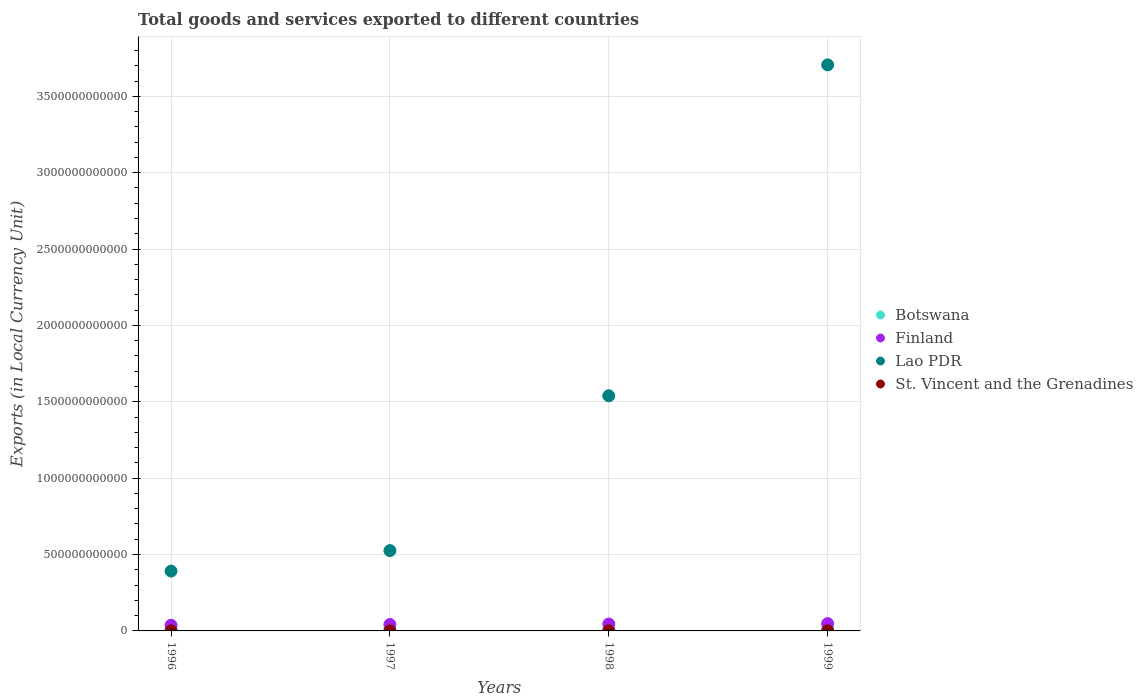What is the Amount of goods and services exports in Botswana in 1999?
Offer a very short reply. 1.40e+1. Across all years, what is the maximum Amount of goods and services exports in St. Vincent and the Grenadines?
Give a very brief answer. 4.78e+08. Across all years, what is the minimum Amount of goods and services exports in Botswana?
Offer a terse response. 8.67e+09. In which year was the Amount of goods and services exports in St. Vincent and the Grenadines minimum?
Make the answer very short. 1997. What is the total Amount of goods and services exports in Lao PDR in the graph?
Your answer should be compact. 6.16e+12. What is the difference between the Amount of goods and services exports in Lao PDR in 1997 and that in 1999?
Offer a very short reply. -3.18e+12. What is the difference between the Amount of goods and services exports in Botswana in 1997 and the Amount of goods and services exports in Lao PDR in 1999?
Make the answer very short. -3.69e+12. What is the average Amount of goods and services exports in St. Vincent and the Grenadines per year?
Offer a terse response. 4.27e+08. In the year 1999, what is the difference between the Amount of goods and services exports in Botswana and Amount of goods and services exports in St. Vincent and the Grenadines?
Make the answer very short. 1.35e+1. What is the ratio of the Amount of goods and services exports in St. Vincent and the Grenadines in 1997 to that in 1998?
Your answer should be very brief. 0.94. Is the difference between the Amount of goods and services exports in Botswana in 1996 and 1998 greater than the difference between the Amount of goods and services exports in St. Vincent and the Grenadines in 1996 and 1998?
Ensure brevity in your answer.  No. What is the difference between the highest and the second highest Amount of goods and services exports in Botswana?
Your answer should be very brief. 2.84e+09. What is the difference between the highest and the lowest Amount of goods and services exports in Lao PDR?
Keep it short and to the point. 3.31e+12. Is the sum of the Amount of goods and services exports in St. Vincent and the Grenadines in 1996 and 1999 greater than the maximum Amount of goods and services exports in Botswana across all years?
Offer a very short reply. No. Is the Amount of goods and services exports in St. Vincent and the Grenadines strictly greater than the Amount of goods and services exports in Finland over the years?
Your answer should be very brief. No. What is the difference between two consecutive major ticks on the Y-axis?
Provide a short and direct response. 5.00e+11. Are the values on the major ticks of Y-axis written in scientific E-notation?
Keep it short and to the point. No. Where does the legend appear in the graph?
Your answer should be very brief. Center right. How are the legend labels stacked?
Your response must be concise. Vertical. What is the title of the graph?
Offer a very short reply. Total goods and services exported to different countries. What is the label or title of the Y-axis?
Your answer should be compact. Exports (in Local Currency Unit). What is the Exports (in Local Currency Unit) in Botswana in 1996?
Your answer should be very brief. 8.67e+09. What is the Exports (in Local Currency Unit) in Finland in 1996?
Your answer should be very brief. 3.71e+1. What is the Exports (in Local Currency Unit) of Lao PDR in 1996?
Give a very brief answer. 3.92e+11. What is the Exports (in Local Currency Unit) in St. Vincent and the Grenadines in 1996?
Your response must be concise. 4.03e+08. What is the Exports (in Local Currency Unit) in Botswana in 1997?
Make the answer very short. 1.12e+1. What is the Exports (in Local Currency Unit) in Finland in 1997?
Offer a terse response. 4.19e+1. What is the Exports (in Local Currency Unit) in Lao PDR in 1997?
Ensure brevity in your answer.  5.26e+11. What is the Exports (in Local Currency Unit) in St. Vincent and the Grenadines in 1997?
Give a very brief answer. 4.01e+08. What is the Exports (in Local Currency Unit) in Botswana in 1998?
Offer a very short reply. 9.98e+09. What is the Exports (in Local Currency Unit) in Finland in 1998?
Provide a succinct answer. 4.51e+1. What is the Exports (in Local Currency Unit) of Lao PDR in 1998?
Provide a succinct answer. 1.54e+12. What is the Exports (in Local Currency Unit) of St. Vincent and the Grenadines in 1998?
Your answer should be very brief. 4.25e+08. What is the Exports (in Local Currency Unit) in Botswana in 1999?
Keep it short and to the point. 1.40e+1. What is the Exports (in Local Currency Unit) of Finland in 1999?
Offer a terse response. 4.77e+1. What is the Exports (in Local Currency Unit) in Lao PDR in 1999?
Your answer should be very brief. 3.71e+12. What is the Exports (in Local Currency Unit) in St. Vincent and the Grenadines in 1999?
Provide a short and direct response. 4.78e+08. Across all years, what is the maximum Exports (in Local Currency Unit) in Botswana?
Offer a very short reply. 1.40e+1. Across all years, what is the maximum Exports (in Local Currency Unit) in Finland?
Your answer should be compact. 4.77e+1. Across all years, what is the maximum Exports (in Local Currency Unit) of Lao PDR?
Keep it short and to the point. 3.71e+12. Across all years, what is the maximum Exports (in Local Currency Unit) of St. Vincent and the Grenadines?
Your answer should be compact. 4.78e+08. Across all years, what is the minimum Exports (in Local Currency Unit) in Botswana?
Offer a very short reply. 8.67e+09. Across all years, what is the minimum Exports (in Local Currency Unit) in Finland?
Provide a succinct answer. 3.71e+1. Across all years, what is the minimum Exports (in Local Currency Unit) in Lao PDR?
Offer a very short reply. 3.92e+11. Across all years, what is the minimum Exports (in Local Currency Unit) of St. Vincent and the Grenadines?
Keep it short and to the point. 4.01e+08. What is the total Exports (in Local Currency Unit) in Botswana in the graph?
Give a very brief answer. 4.38e+1. What is the total Exports (in Local Currency Unit) of Finland in the graph?
Your answer should be very brief. 1.72e+11. What is the total Exports (in Local Currency Unit) of Lao PDR in the graph?
Provide a succinct answer. 6.16e+12. What is the total Exports (in Local Currency Unit) in St. Vincent and the Grenadines in the graph?
Offer a very short reply. 1.71e+09. What is the difference between the Exports (in Local Currency Unit) of Botswana in 1996 and that in 1997?
Offer a terse response. -2.48e+09. What is the difference between the Exports (in Local Currency Unit) of Finland in 1996 and that in 1997?
Provide a succinct answer. -4.78e+09. What is the difference between the Exports (in Local Currency Unit) in Lao PDR in 1996 and that in 1997?
Provide a short and direct response. -1.34e+11. What is the difference between the Exports (in Local Currency Unit) of St. Vincent and the Grenadines in 1996 and that in 1997?
Provide a short and direct response. 2.41e+06. What is the difference between the Exports (in Local Currency Unit) in Botswana in 1996 and that in 1998?
Make the answer very short. -1.30e+09. What is the difference between the Exports (in Local Currency Unit) in Finland in 1996 and that in 1998?
Offer a very short reply. -8.03e+09. What is the difference between the Exports (in Local Currency Unit) in Lao PDR in 1996 and that in 1998?
Ensure brevity in your answer.  -1.15e+12. What is the difference between the Exports (in Local Currency Unit) of St. Vincent and the Grenadines in 1996 and that in 1998?
Your response must be concise. -2.21e+07. What is the difference between the Exports (in Local Currency Unit) in Botswana in 1996 and that in 1999?
Your answer should be compact. -5.32e+09. What is the difference between the Exports (in Local Currency Unit) of Finland in 1996 and that in 1999?
Provide a succinct answer. -1.06e+1. What is the difference between the Exports (in Local Currency Unit) in Lao PDR in 1996 and that in 1999?
Your response must be concise. -3.31e+12. What is the difference between the Exports (in Local Currency Unit) of St. Vincent and the Grenadines in 1996 and that in 1999?
Make the answer very short. -7.55e+07. What is the difference between the Exports (in Local Currency Unit) of Botswana in 1997 and that in 1998?
Make the answer very short. 1.18e+09. What is the difference between the Exports (in Local Currency Unit) in Finland in 1997 and that in 1998?
Offer a very short reply. -3.24e+09. What is the difference between the Exports (in Local Currency Unit) of Lao PDR in 1997 and that in 1998?
Your response must be concise. -1.01e+12. What is the difference between the Exports (in Local Currency Unit) of St. Vincent and the Grenadines in 1997 and that in 1998?
Your answer should be very brief. -2.45e+07. What is the difference between the Exports (in Local Currency Unit) of Botswana in 1997 and that in 1999?
Your answer should be compact. -2.84e+09. What is the difference between the Exports (in Local Currency Unit) of Finland in 1997 and that in 1999?
Ensure brevity in your answer.  -5.87e+09. What is the difference between the Exports (in Local Currency Unit) in Lao PDR in 1997 and that in 1999?
Keep it short and to the point. -3.18e+12. What is the difference between the Exports (in Local Currency Unit) in St. Vincent and the Grenadines in 1997 and that in 1999?
Your response must be concise. -7.79e+07. What is the difference between the Exports (in Local Currency Unit) in Botswana in 1998 and that in 1999?
Provide a short and direct response. -4.02e+09. What is the difference between the Exports (in Local Currency Unit) of Finland in 1998 and that in 1999?
Keep it short and to the point. -2.62e+09. What is the difference between the Exports (in Local Currency Unit) in Lao PDR in 1998 and that in 1999?
Keep it short and to the point. -2.17e+12. What is the difference between the Exports (in Local Currency Unit) in St. Vincent and the Grenadines in 1998 and that in 1999?
Offer a very short reply. -5.34e+07. What is the difference between the Exports (in Local Currency Unit) of Botswana in 1996 and the Exports (in Local Currency Unit) of Finland in 1997?
Your answer should be very brief. -3.32e+1. What is the difference between the Exports (in Local Currency Unit) in Botswana in 1996 and the Exports (in Local Currency Unit) in Lao PDR in 1997?
Your answer should be compact. -5.17e+11. What is the difference between the Exports (in Local Currency Unit) in Botswana in 1996 and the Exports (in Local Currency Unit) in St. Vincent and the Grenadines in 1997?
Provide a succinct answer. 8.27e+09. What is the difference between the Exports (in Local Currency Unit) of Finland in 1996 and the Exports (in Local Currency Unit) of Lao PDR in 1997?
Provide a succinct answer. -4.89e+11. What is the difference between the Exports (in Local Currency Unit) of Finland in 1996 and the Exports (in Local Currency Unit) of St. Vincent and the Grenadines in 1997?
Give a very brief answer. 3.67e+1. What is the difference between the Exports (in Local Currency Unit) of Lao PDR in 1996 and the Exports (in Local Currency Unit) of St. Vincent and the Grenadines in 1997?
Offer a very short reply. 3.91e+11. What is the difference between the Exports (in Local Currency Unit) of Botswana in 1996 and the Exports (in Local Currency Unit) of Finland in 1998?
Give a very brief answer. -3.64e+1. What is the difference between the Exports (in Local Currency Unit) of Botswana in 1996 and the Exports (in Local Currency Unit) of Lao PDR in 1998?
Your response must be concise. -1.53e+12. What is the difference between the Exports (in Local Currency Unit) in Botswana in 1996 and the Exports (in Local Currency Unit) in St. Vincent and the Grenadines in 1998?
Your answer should be compact. 8.25e+09. What is the difference between the Exports (in Local Currency Unit) of Finland in 1996 and the Exports (in Local Currency Unit) of Lao PDR in 1998?
Offer a very short reply. -1.50e+12. What is the difference between the Exports (in Local Currency Unit) in Finland in 1996 and the Exports (in Local Currency Unit) in St. Vincent and the Grenadines in 1998?
Offer a terse response. 3.67e+1. What is the difference between the Exports (in Local Currency Unit) of Lao PDR in 1996 and the Exports (in Local Currency Unit) of St. Vincent and the Grenadines in 1998?
Keep it short and to the point. 3.91e+11. What is the difference between the Exports (in Local Currency Unit) in Botswana in 1996 and the Exports (in Local Currency Unit) in Finland in 1999?
Provide a short and direct response. -3.91e+1. What is the difference between the Exports (in Local Currency Unit) of Botswana in 1996 and the Exports (in Local Currency Unit) of Lao PDR in 1999?
Provide a succinct answer. -3.70e+12. What is the difference between the Exports (in Local Currency Unit) of Botswana in 1996 and the Exports (in Local Currency Unit) of St. Vincent and the Grenadines in 1999?
Your response must be concise. 8.20e+09. What is the difference between the Exports (in Local Currency Unit) in Finland in 1996 and the Exports (in Local Currency Unit) in Lao PDR in 1999?
Provide a short and direct response. -3.67e+12. What is the difference between the Exports (in Local Currency Unit) in Finland in 1996 and the Exports (in Local Currency Unit) in St. Vincent and the Grenadines in 1999?
Provide a short and direct response. 3.66e+1. What is the difference between the Exports (in Local Currency Unit) of Lao PDR in 1996 and the Exports (in Local Currency Unit) of St. Vincent and the Grenadines in 1999?
Offer a very short reply. 3.91e+11. What is the difference between the Exports (in Local Currency Unit) of Botswana in 1997 and the Exports (in Local Currency Unit) of Finland in 1998?
Your response must be concise. -3.39e+1. What is the difference between the Exports (in Local Currency Unit) in Botswana in 1997 and the Exports (in Local Currency Unit) in Lao PDR in 1998?
Your answer should be compact. -1.53e+12. What is the difference between the Exports (in Local Currency Unit) of Botswana in 1997 and the Exports (in Local Currency Unit) of St. Vincent and the Grenadines in 1998?
Your answer should be very brief. 1.07e+1. What is the difference between the Exports (in Local Currency Unit) of Finland in 1997 and the Exports (in Local Currency Unit) of Lao PDR in 1998?
Your answer should be compact. -1.50e+12. What is the difference between the Exports (in Local Currency Unit) in Finland in 1997 and the Exports (in Local Currency Unit) in St. Vincent and the Grenadines in 1998?
Your answer should be compact. 4.14e+1. What is the difference between the Exports (in Local Currency Unit) of Lao PDR in 1997 and the Exports (in Local Currency Unit) of St. Vincent and the Grenadines in 1998?
Your answer should be very brief. 5.25e+11. What is the difference between the Exports (in Local Currency Unit) in Botswana in 1997 and the Exports (in Local Currency Unit) in Finland in 1999?
Your answer should be compact. -3.66e+1. What is the difference between the Exports (in Local Currency Unit) in Botswana in 1997 and the Exports (in Local Currency Unit) in Lao PDR in 1999?
Provide a short and direct response. -3.69e+12. What is the difference between the Exports (in Local Currency Unit) of Botswana in 1997 and the Exports (in Local Currency Unit) of St. Vincent and the Grenadines in 1999?
Provide a short and direct response. 1.07e+1. What is the difference between the Exports (in Local Currency Unit) of Finland in 1997 and the Exports (in Local Currency Unit) of Lao PDR in 1999?
Your answer should be compact. -3.66e+12. What is the difference between the Exports (in Local Currency Unit) in Finland in 1997 and the Exports (in Local Currency Unit) in St. Vincent and the Grenadines in 1999?
Your response must be concise. 4.14e+1. What is the difference between the Exports (in Local Currency Unit) of Lao PDR in 1997 and the Exports (in Local Currency Unit) of St. Vincent and the Grenadines in 1999?
Make the answer very short. 5.25e+11. What is the difference between the Exports (in Local Currency Unit) in Botswana in 1998 and the Exports (in Local Currency Unit) in Finland in 1999?
Provide a short and direct response. -3.77e+1. What is the difference between the Exports (in Local Currency Unit) in Botswana in 1998 and the Exports (in Local Currency Unit) in Lao PDR in 1999?
Your answer should be very brief. -3.70e+12. What is the difference between the Exports (in Local Currency Unit) in Botswana in 1998 and the Exports (in Local Currency Unit) in St. Vincent and the Grenadines in 1999?
Provide a succinct answer. 9.50e+09. What is the difference between the Exports (in Local Currency Unit) of Finland in 1998 and the Exports (in Local Currency Unit) of Lao PDR in 1999?
Keep it short and to the point. -3.66e+12. What is the difference between the Exports (in Local Currency Unit) of Finland in 1998 and the Exports (in Local Currency Unit) of St. Vincent and the Grenadines in 1999?
Your answer should be compact. 4.46e+1. What is the difference between the Exports (in Local Currency Unit) in Lao PDR in 1998 and the Exports (in Local Currency Unit) in St. Vincent and the Grenadines in 1999?
Provide a short and direct response. 1.54e+12. What is the average Exports (in Local Currency Unit) in Botswana per year?
Your answer should be compact. 1.10e+1. What is the average Exports (in Local Currency Unit) of Finland per year?
Your response must be concise. 4.29e+1. What is the average Exports (in Local Currency Unit) of Lao PDR per year?
Offer a terse response. 1.54e+12. What is the average Exports (in Local Currency Unit) of St. Vincent and the Grenadines per year?
Keep it short and to the point. 4.27e+08. In the year 1996, what is the difference between the Exports (in Local Currency Unit) in Botswana and Exports (in Local Currency Unit) in Finland?
Your response must be concise. -2.84e+1. In the year 1996, what is the difference between the Exports (in Local Currency Unit) in Botswana and Exports (in Local Currency Unit) in Lao PDR?
Ensure brevity in your answer.  -3.83e+11. In the year 1996, what is the difference between the Exports (in Local Currency Unit) in Botswana and Exports (in Local Currency Unit) in St. Vincent and the Grenadines?
Give a very brief answer. 8.27e+09. In the year 1996, what is the difference between the Exports (in Local Currency Unit) in Finland and Exports (in Local Currency Unit) in Lao PDR?
Provide a short and direct response. -3.55e+11. In the year 1996, what is the difference between the Exports (in Local Currency Unit) of Finland and Exports (in Local Currency Unit) of St. Vincent and the Grenadines?
Your response must be concise. 3.67e+1. In the year 1996, what is the difference between the Exports (in Local Currency Unit) of Lao PDR and Exports (in Local Currency Unit) of St. Vincent and the Grenadines?
Your response must be concise. 3.91e+11. In the year 1997, what is the difference between the Exports (in Local Currency Unit) in Botswana and Exports (in Local Currency Unit) in Finland?
Your answer should be compact. -3.07e+1. In the year 1997, what is the difference between the Exports (in Local Currency Unit) in Botswana and Exports (in Local Currency Unit) in Lao PDR?
Keep it short and to the point. -5.15e+11. In the year 1997, what is the difference between the Exports (in Local Currency Unit) of Botswana and Exports (in Local Currency Unit) of St. Vincent and the Grenadines?
Provide a short and direct response. 1.08e+1. In the year 1997, what is the difference between the Exports (in Local Currency Unit) of Finland and Exports (in Local Currency Unit) of Lao PDR?
Make the answer very short. -4.84e+11. In the year 1997, what is the difference between the Exports (in Local Currency Unit) in Finland and Exports (in Local Currency Unit) in St. Vincent and the Grenadines?
Provide a short and direct response. 4.15e+1. In the year 1997, what is the difference between the Exports (in Local Currency Unit) of Lao PDR and Exports (in Local Currency Unit) of St. Vincent and the Grenadines?
Your response must be concise. 5.26e+11. In the year 1998, what is the difference between the Exports (in Local Currency Unit) of Botswana and Exports (in Local Currency Unit) of Finland?
Ensure brevity in your answer.  -3.51e+1. In the year 1998, what is the difference between the Exports (in Local Currency Unit) of Botswana and Exports (in Local Currency Unit) of Lao PDR?
Ensure brevity in your answer.  -1.53e+12. In the year 1998, what is the difference between the Exports (in Local Currency Unit) of Botswana and Exports (in Local Currency Unit) of St. Vincent and the Grenadines?
Keep it short and to the point. 9.55e+09. In the year 1998, what is the difference between the Exports (in Local Currency Unit) in Finland and Exports (in Local Currency Unit) in Lao PDR?
Your answer should be very brief. -1.49e+12. In the year 1998, what is the difference between the Exports (in Local Currency Unit) in Finland and Exports (in Local Currency Unit) in St. Vincent and the Grenadines?
Your answer should be very brief. 4.47e+1. In the year 1998, what is the difference between the Exports (in Local Currency Unit) of Lao PDR and Exports (in Local Currency Unit) of St. Vincent and the Grenadines?
Ensure brevity in your answer.  1.54e+12. In the year 1999, what is the difference between the Exports (in Local Currency Unit) of Botswana and Exports (in Local Currency Unit) of Finland?
Offer a terse response. -3.37e+1. In the year 1999, what is the difference between the Exports (in Local Currency Unit) of Botswana and Exports (in Local Currency Unit) of Lao PDR?
Give a very brief answer. -3.69e+12. In the year 1999, what is the difference between the Exports (in Local Currency Unit) in Botswana and Exports (in Local Currency Unit) in St. Vincent and the Grenadines?
Ensure brevity in your answer.  1.35e+1. In the year 1999, what is the difference between the Exports (in Local Currency Unit) of Finland and Exports (in Local Currency Unit) of Lao PDR?
Provide a succinct answer. -3.66e+12. In the year 1999, what is the difference between the Exports (in Local Currency Unit) of Finland and Exports (in Local Currency Unit) of St. Vincent and the Grenadines?
Provide a short and direct response. 4.72e+1. In the year 1999, what is the difference between the Exports (in Local Currency Unit) of Lao PDR and Exports (in Local Currency Unit) of St. Vincent and the Grenadines?
Provide a succinct answer. 3.71e+12. What is the ratio of the Exports (in Local Currency Unit) in Botswana in 1996 to that in 1997?
Your answer should be very brief. 0.78. What is the ratio of the Exports (in Local Currency Unit) of Finland in 1996 to that in 1997?
Give a very brief answer. 0.89. What is the ratio of the Exports (in Local Currency Unit) in Lao PDR in 1996 to that in 1997?
Your response must be concise. 0.74. What is the ratio of the Exports (in Local Currency Unit) of St. Vincent and the Grenadines in 1996 to that in 1997?
Provide a short and direct response. 1.01. What is the ratio of the Exports (in Local Currency Unit) in Botswana in 1996 to that in 1998?
Provide a short and direct response. 0.87. What is the ratio of the Exports (in Local Currency Unit) in Finland in 1996 to that in 1998?
Provide a short and direct response. 0.82. What is the ratio of the Exports (in Local Currency Unit) of Lao PDR in 1996 to that in 1998?
Your response must be concise. 0.25. What is the ratio of the Exports (in Local Currency Unit) in St. Vincent and the Grenadines in 1996 to that in 1998?
Offer a very short reply. 0.95. What is the ratio of the Exports (in Local Currency Unit) of Botswana in 1996 to that in 1999?
Offer a very short reply. 0.62. What is the ratio of the Exports (in Local Currency Unit) in Finland in 1996 to that in 1999?
Provide a succinct answer. 0.78. What is the ratio of the Exports (in Local Currency Unit) of Lao PDR in 1996 to that in 1999?
Offer a very short reply. 0.11. What is the ratio of the Exports (in Local Currency Unit) in St. Vincent and the Grenadines in 1996 to that in 1999?
Make the answer very short. 0.84. What is the ratio of the Exports (in Local Currency Unit) in Botswana in 1997 to that in 1998?
Your answer should be very brief. 1.12. What is the ratio of the Exports (in Local Currency Unit) in Finland in 1997 to that in 1998?
Your answer should be very brief. 0.93. What is the ratio of the Exports (in Local Currency Unit) of Lao PDR in 1997 to that in 1998?
Ensure brevity in your answer.  0.34. What is the ratio of the Exports (in Local Currency Unit) of St. Vincent and the Grenadines in 1997 to that in 1998?
Your answer should be very brief. 0.94. What is the ratio of the Exports (in Local Currency Unit) in Botswana in 1997 to that in 1999?
Offer a terse response. 0.8. What is the ratio of the Exports (in Local Currency Unit) in Finland in 1997 to that in 1999?
Give a very brief answer. 0.88. What is the ratio of the Exports (in Local Currency Unit) of Lao PDR in 1997 to that in 1999?
Give a very brief answer. 0.14. What is the ratio of the Exports (in Local Currency Unit) in St. Vincent and the Grenadines in 1997 to that in 1999?
Make the answer very short. 0.84. What is the ratio of the Exports (in Local Currency Unit) of Botswana in 1998 to that in 1999?
Offer a terse response. 0.71. What is the ratio of the Exports (in Local Currency Unit) in Finland in 1998 to that in 1999?
Provide a succinct answer. 0.95. What is the ratio of the Exports (in Local Currency Unit) of Lao PDR in 1998 to that in 1999?
Offer a terse response. 0.42. What is the ratio of the Exports (in Local Currency Unit) of St. Vincent and the Grenadines in 1998 to that in 1999?
Keep it short and to the point. 0.89. What is the difference between the highest and the second highest Exports (in Local Currency Unit) in Botswana?
Keep it short and to the point. 2.84e+09. What is the difference between the highest and the second highest Exports (in Local Currency Unit) of Finland?
Your response must be concise. 2.62e+09. What is the difference between the highest and the second highest Exports (in Local Currency Unit) of Lao PDR?
Provide a short and direct response. 2.17e+12. What is the difference between the highest and the second highest Exports (in Local Currency Unit) in St. Vincent and the Grenadines?
Your response must be concise. 5.34e+07. What is the difference between the highest and the lowest Exports (in Local Currency Unit) in Botswana?
Make the answer very short. 5.32e+09. What is the difference between the highest and the lowest Exports (in Local Currency Unit) in Finland?
Give a very brief answer. 1.06e+1. What is the difference between the highest and the lowest Exports (in Local Currency Unit) of Lao PDR?
Offer a terse response. 3.31e+12. What is the difference between the highest and the lowest Exports (in Local Currency Unit) of St. Vincent and the Grenadines?
Your answer should be compact. 7.79e+07. 